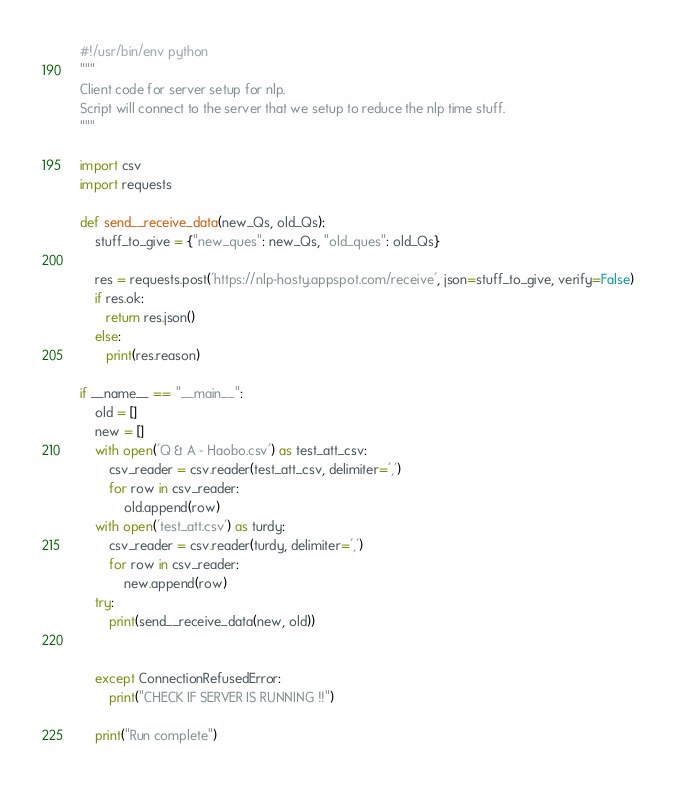<code> <loc_0><loc_0><loc_500><loc_500><_Python_>#!/usr/bin/env python
"""
Client code for server setup for nlp.
Script will connect to the server that we setup to reduce the nlp time stuff.
"""

import csv
import requests

def send__receive_data(new_Qs, old_Qs):
    stuff_to_give = {"new_ques": new_Qs, "old_ques": old_Qs}

    res = requests.post('https://nlp-hosty.appspot.com/receive', json=stuff_to_give, verify=False)
    if res.ok:
       return res.json()
    else:
       print(res.reason)

if __name__ == "__main__":
    old = []
    new = []
    with open('Q & A - Haobo.csv') as test_att_csv:
        csv_reader = csv.reader(test_att_csv, delimiter=',')
        for row in csv_reader:
            old.append(row)
    with open('test_att.csv') as turdy:
        csv_reader = csv.reader(turdy, delimiter=',')
        for row in csv_reader:
            new.append(row)
    try:
        print(send__receive_data(new, old))


    except ConnectionRefusedError:
        print("CHECK IF SERVER IS RUNNING !!")

    print("Run complete")
</code> 